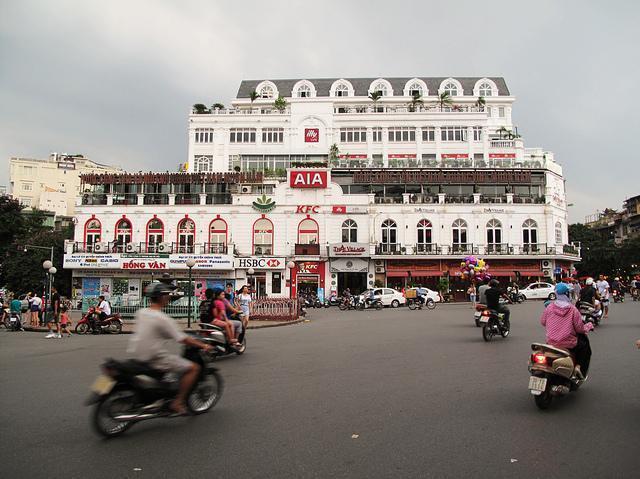What sort of bird meats are sold in this large building among other things?
Indicate the correct response and explain using: 'Answer: answer
Rationale: rationale.'
Options: Chicken, dove, duck, pigeon. Answer: chicken.
Rationale: A building has a kfc logo. kfc sells chicken. 